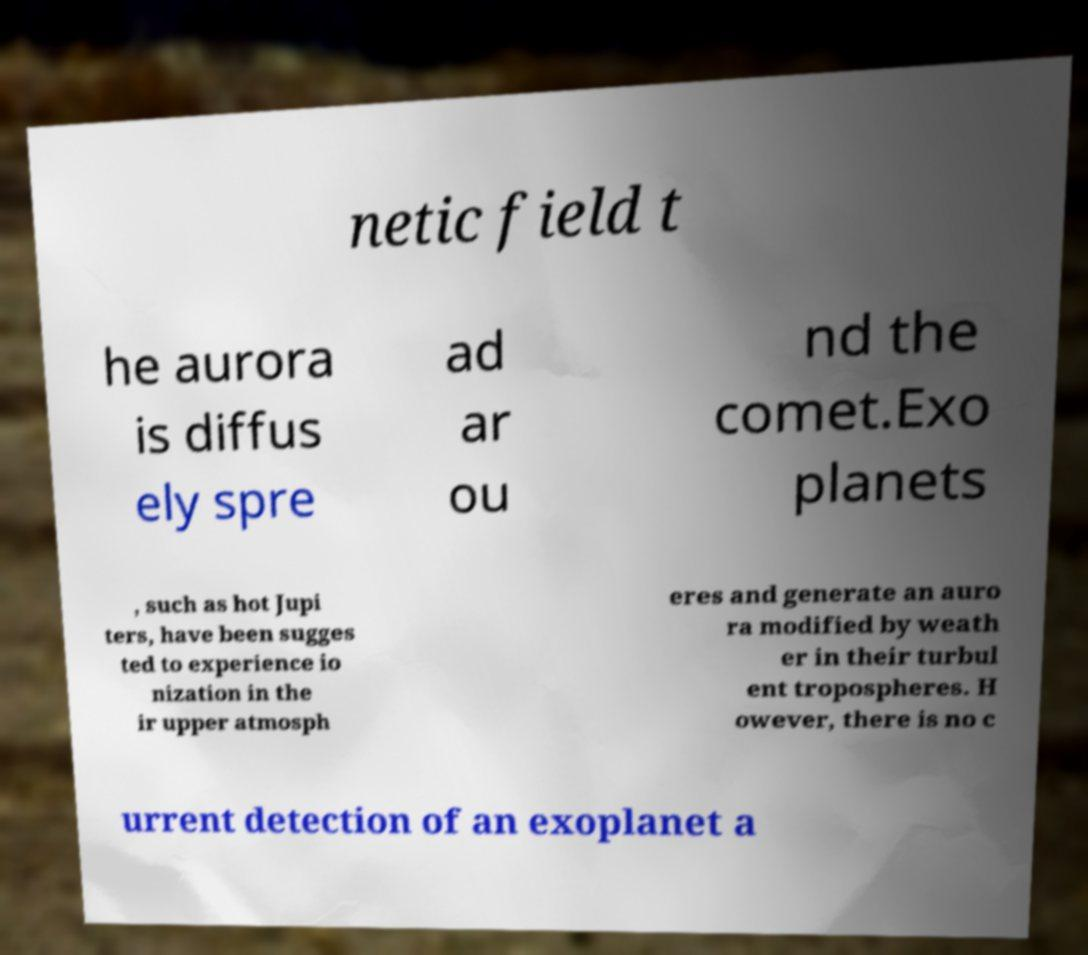I need the written content from this picture converted into text. Can you do that? netic field t he aurora is diffus ely spre ad ar ou nd the comet.Exo planets , such as hot Jupi ters, have been sugges ted to experience io nization in the ir upper atmosph eres and generate an auro ra modified by weath er in their turbul ent tropospheres. H owever, there is no c urrent detection of an exoplanet a 